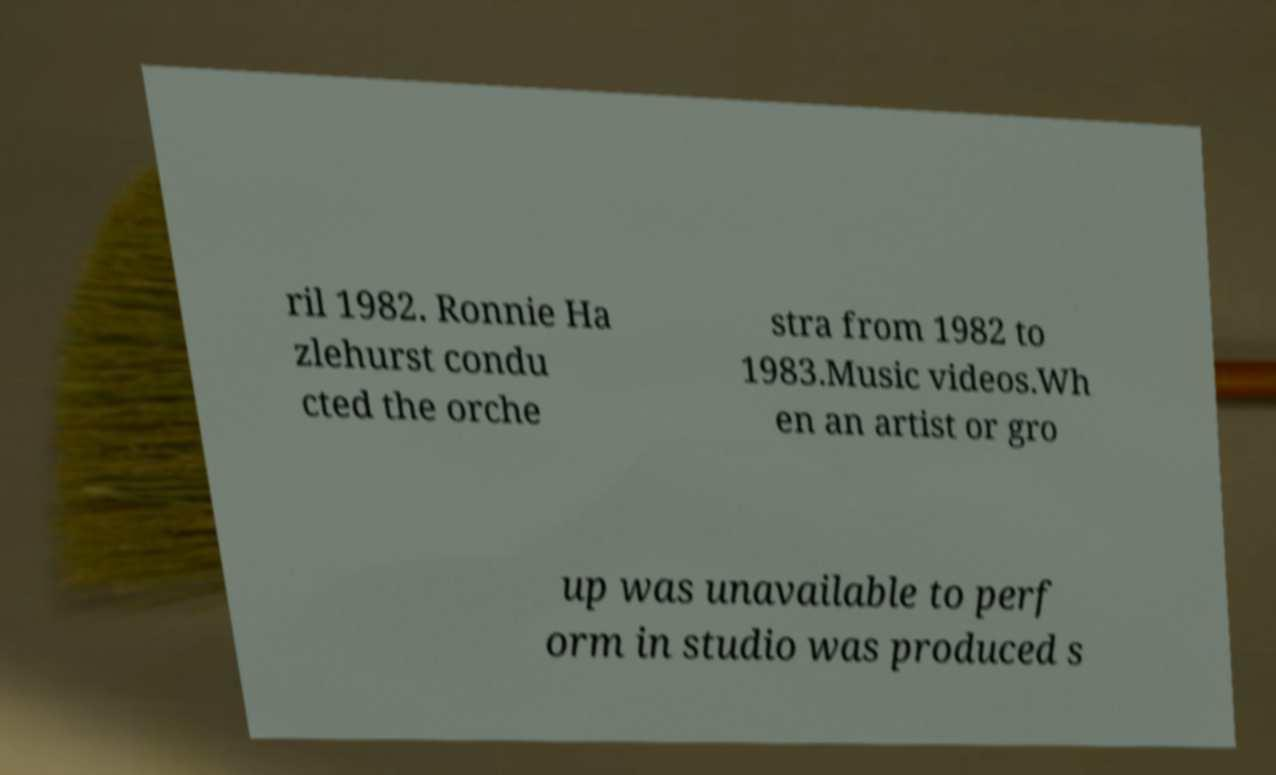There's text embedded in this image that I need extracted. Can you transcribe it verbatim? ril 1982. Ronnie Ha zlehurst condu cted the orche stra from 1982 to 1983.Music videos.Wh en an artist or gro up was unavailable to perf orm in studio was produced s 